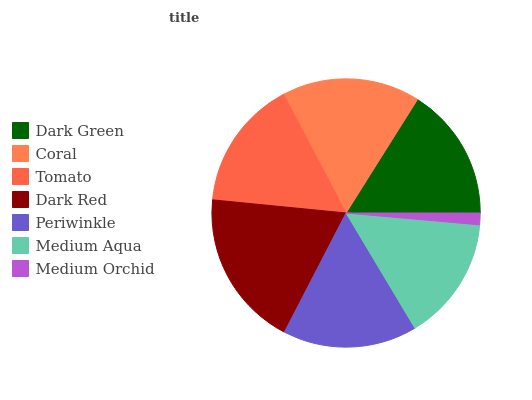Is Medium Orchid the minimum?
Answer yes or no. Yes. Is Dark Red the maximum?
Answer yes or no. Yes. Is Coral the minimum?
Answer yes or no. No. Is Coral the maximum?
Answer yes or no. No. Is Coral greater than Dark Green?
Answer yes or no. Yes. Is Dark Green less than Coral?
Answer yes or no. Yes. Is Dark Green greater than Coral?
Answer yes or no. No. Is Coral less than Dark Green?
Answer yes or no. No. Is Dark Green the high median?
Answer yes or no. Yes. Is Dark Green the low median?
Answer yes or no. Yes. Is Medium Orchid the high median?
Answer yes or no. No. Is Medium Orchid the low median?
Answer yes or no. No. 